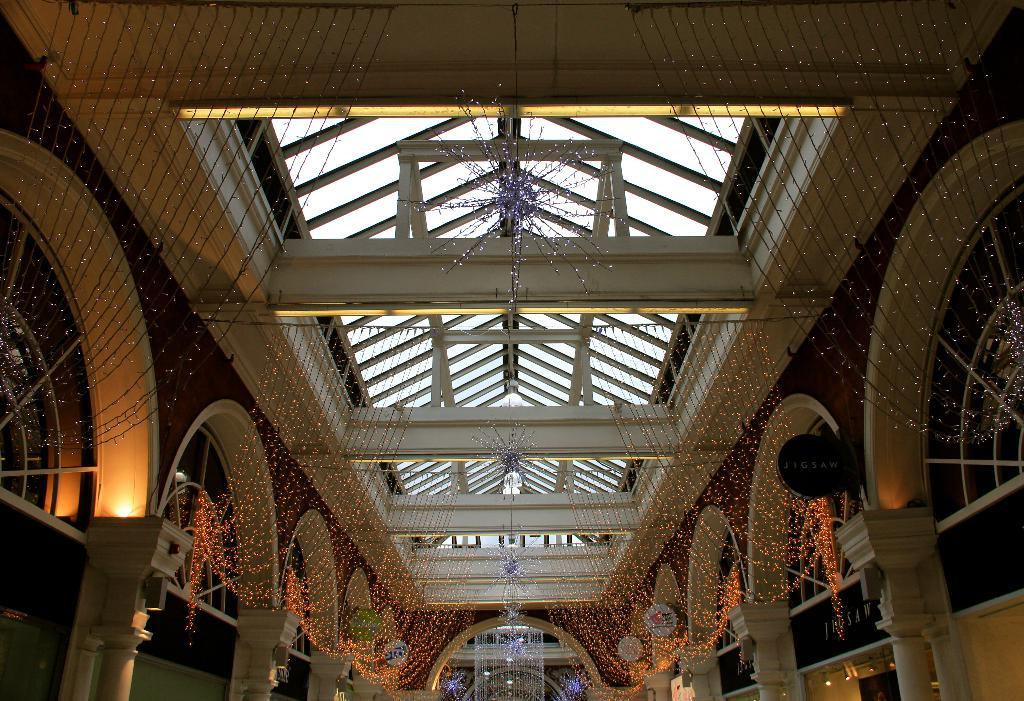What is the main structure in the center of the image? There is a building in the center of the image. What type of architectural feature can be seen in the image? There is a wall and a roof visible in the image. What type of lighting is present in the image? String lights are present in the image. What type of signage is visible in the image? Sign boards are visible in the image. What type of security feature is present in the image? Cameras are present in the image. What type of structural support can be seen in the image? Pillars are visible in the image. What other objects can be seen in the image? There are other objects in the image, but their specific details are not mentioned in the provided facts. What arithmetic problem is being solved on the sign board in the image? There is no arithmetic problem visible on the sign board in the image. Can you tell me how many people are running in the image? There is no indication of people running in the image. 